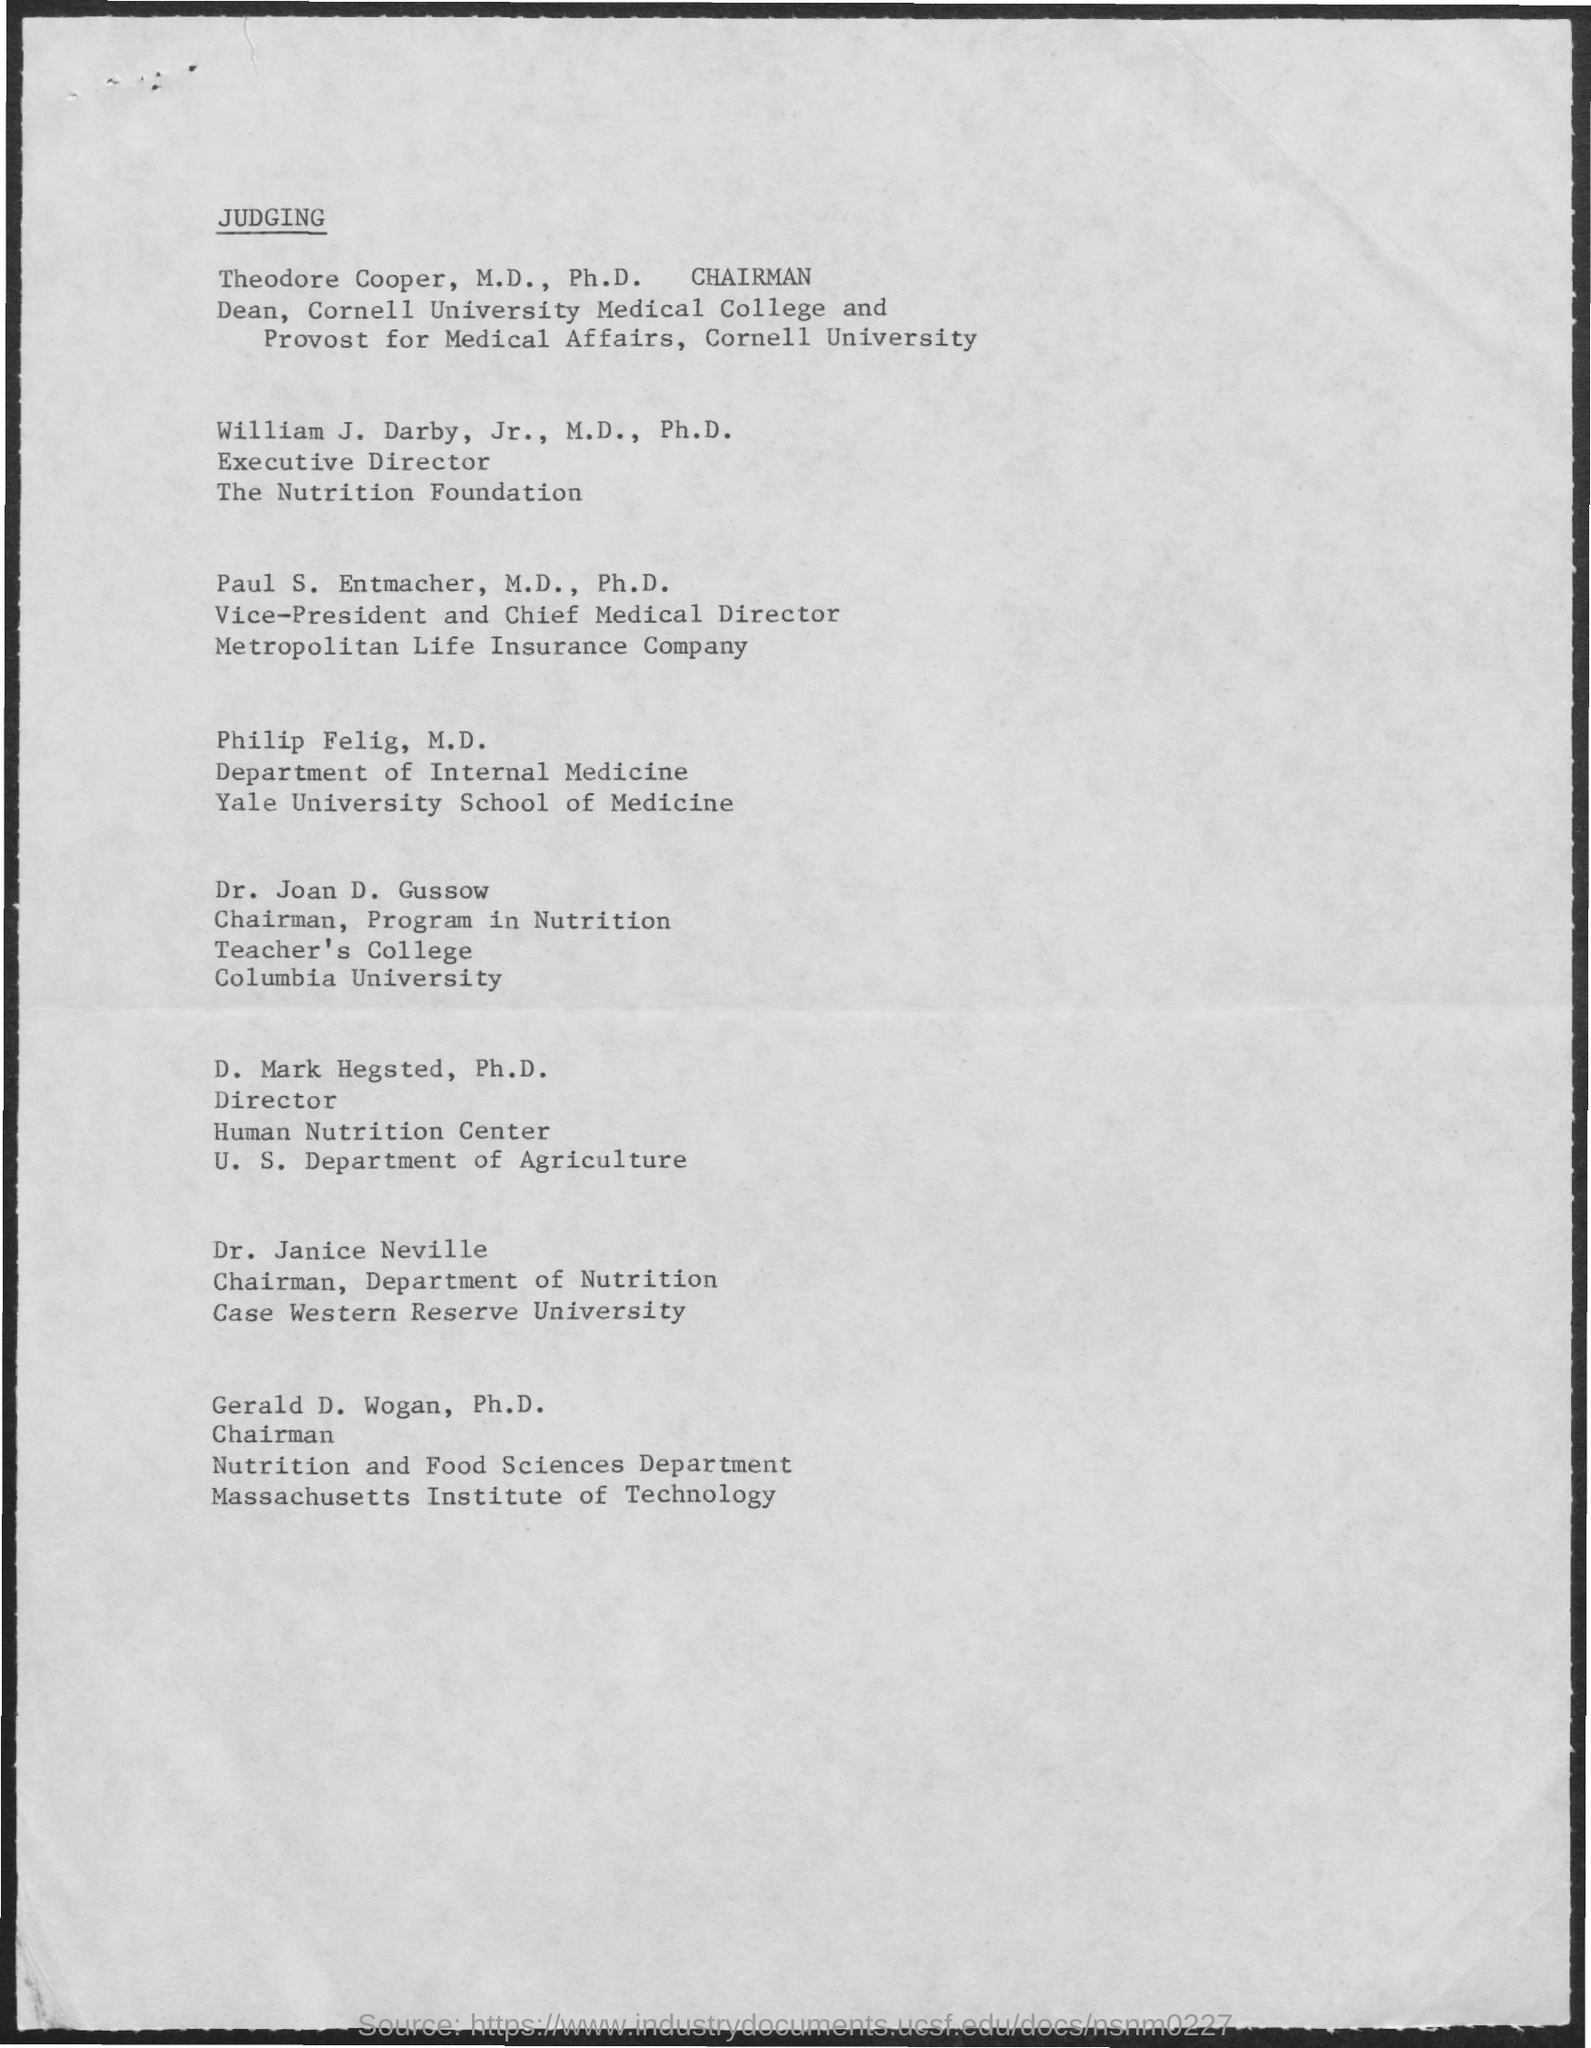What is the Title of the document?
Your response must be concise. Judging. Who is the Dean, Cornell University Medical College?
Provide a succinct answer. Theodore Copper, M.D., Ph.D. Who is the Executive Director of The Nutrition Foundation?
Your answer should be compact. William j. darby. Who is the director of Human Nutrition Center?
Provide a short and direct response. D. Mark Hegsted, Ph.D. Who is the Chairman of Department of Nutrition?
Your answer should be very brief. Dr. Janice Neville. Who is the Chairman of Nutrition and Food Sciences Department?
Keep it short and to the point. Gerald d. wogan. 